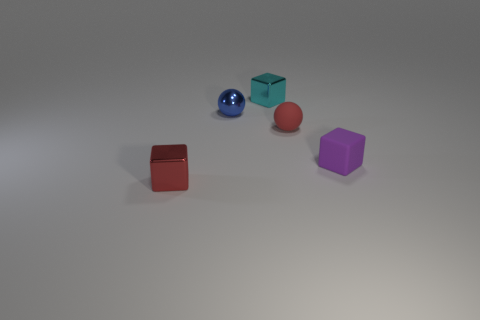Can you tell me the colors of the objects presented? Certainly, there are five objects showcasing different colors: one is blue, another is red, there's a purple one, a red-brown object that might be terracotta, and a sphere that is shiny and metallic blue. Are there any patterns or textures visible on any of the objects? No discernible patterns or textures are present; each object has a uniform color and a matte finish, with the exception of the metallic blue sphere, which has a reflective surface. 